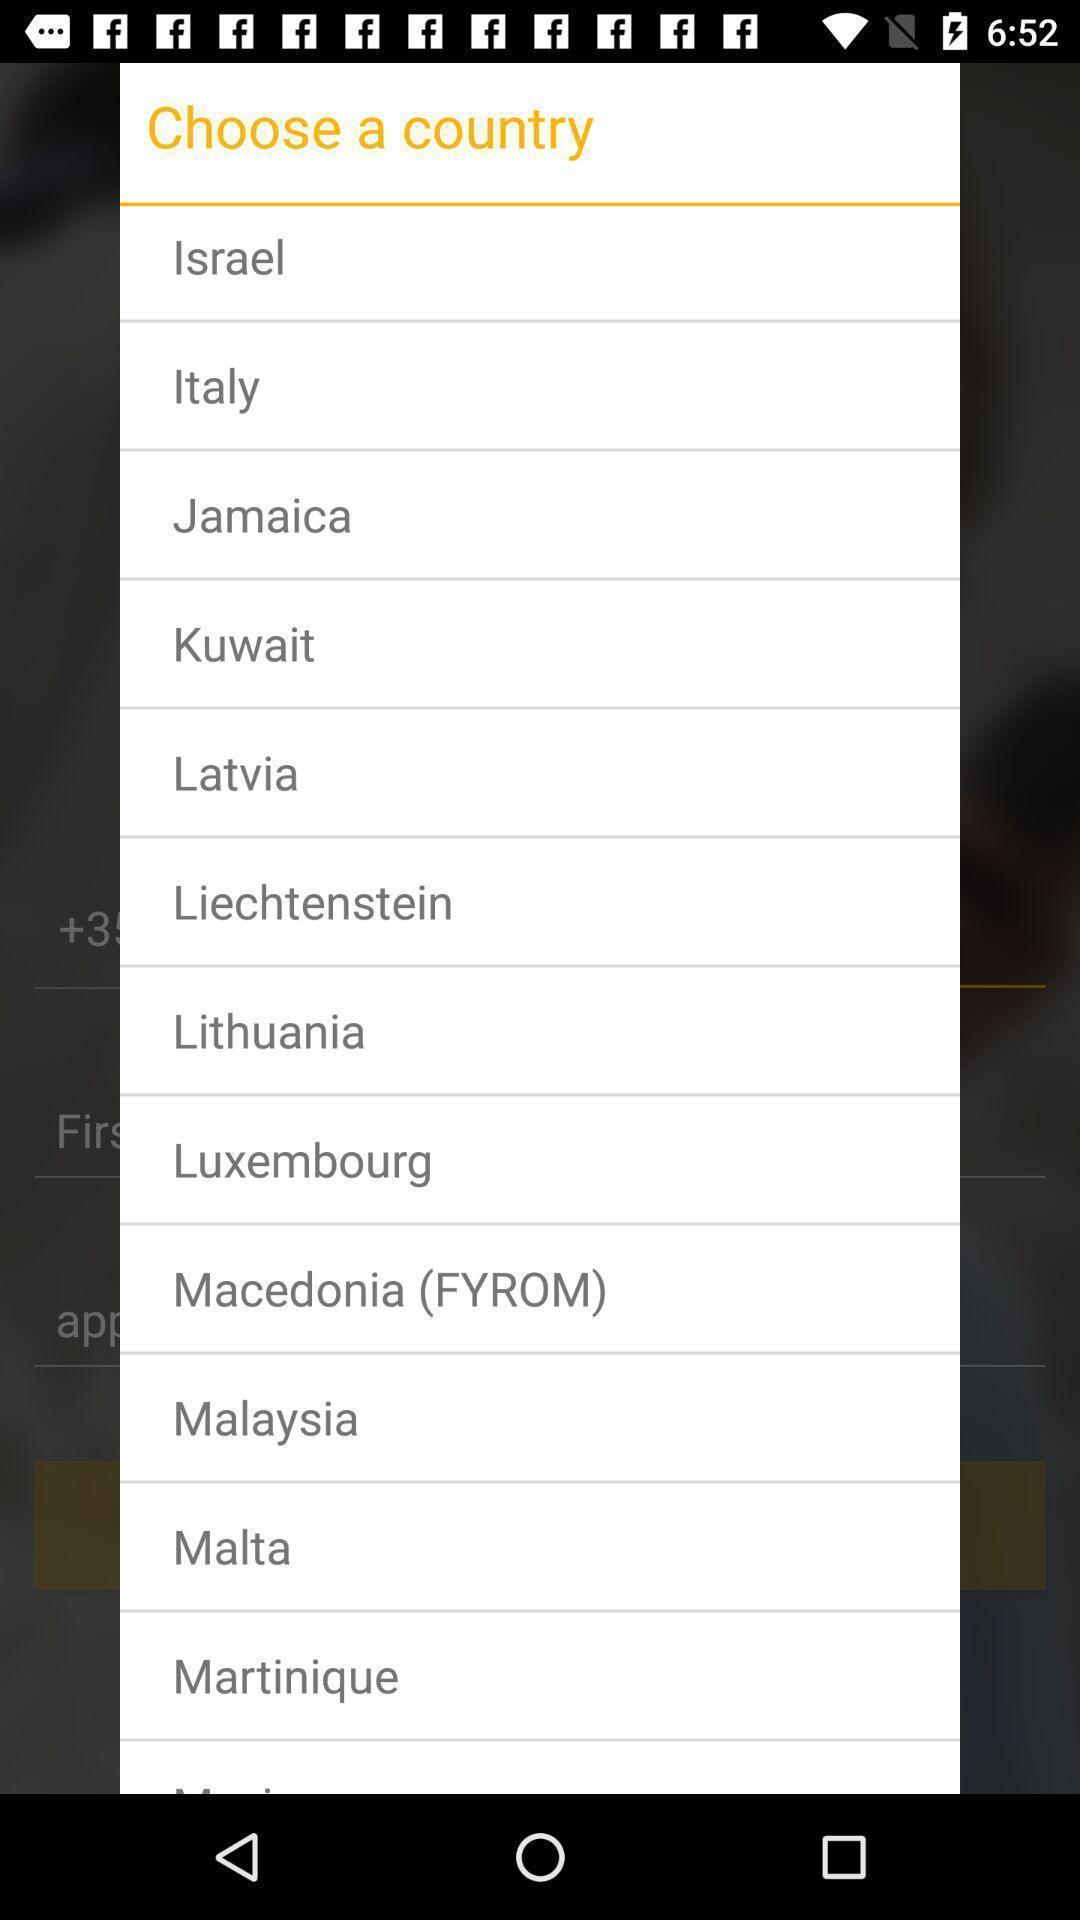Tell me what you see in this picture. Pop up window displaying countries to choose. 